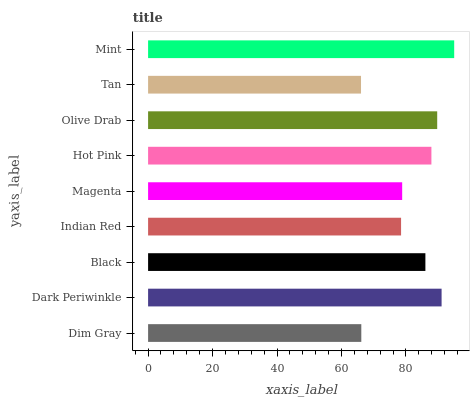Is Tan the minimum?
Answer yes or no. Yes. Is Mint the maximum?
Answer yes or no. Yes. Is Dark Periwinkle the minimum?
Answer yes or no. No. Is Dark Periwinkle the maximum?
Answer yes or no. No. Is Dark Periwinkle greater than Dim Gray?
Answer yes or no. Yes. Is Dim Gray less than Dark Periwinkle?
Answer yes or no. Yes. Is Dim Gray greater than Dark Periwinkle?
Answer yes or no. No. Is Dark Periwinkle less than Dim Gray?
Answer yes or no. No. Is Black the high median?
Answer yes or no. Yes. Is Black the low median?
Answer yes or no. Yes. Is Dark Periwinkle the high median?
Answer yes or no. No. Is Hot Pink the low median?
Answer yes or no. No. 